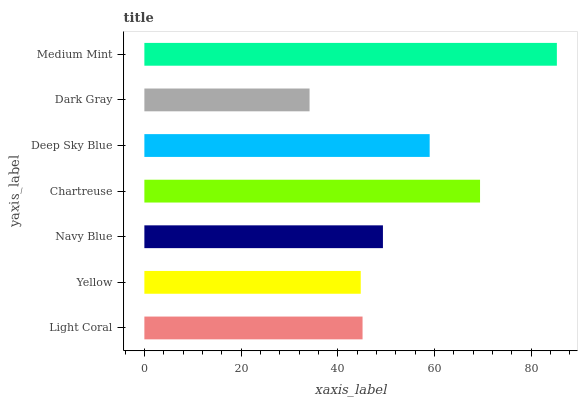Is Dark Gray the minimum?
Answer yes or no. Yes. Is Medium Mint the maximum?
Answer yes or no. Yes. Is Yellow the minimum?
Answer yes or no. No. Is Yellow the maximum?
Answer yes or no. No. Is Light Coral greater than Yellow?
Answer yes or no. Yes. Is Yellow less than Light Coral?
Answer yes or no. Yes. Is Yellow greater than Light Coral?
Answer yes or no. No. Is Light Coral less than Yellow?
Answer yes or no. No. Is Navy Blue the high median?
Answer yes or no. Yes. Is Navy Blue the low median?
Answer yes or no. Yes. Is Light Coral the high median?
Answer yes or no. No. Is Light Coral the low median?
Answer yes or no. No. 